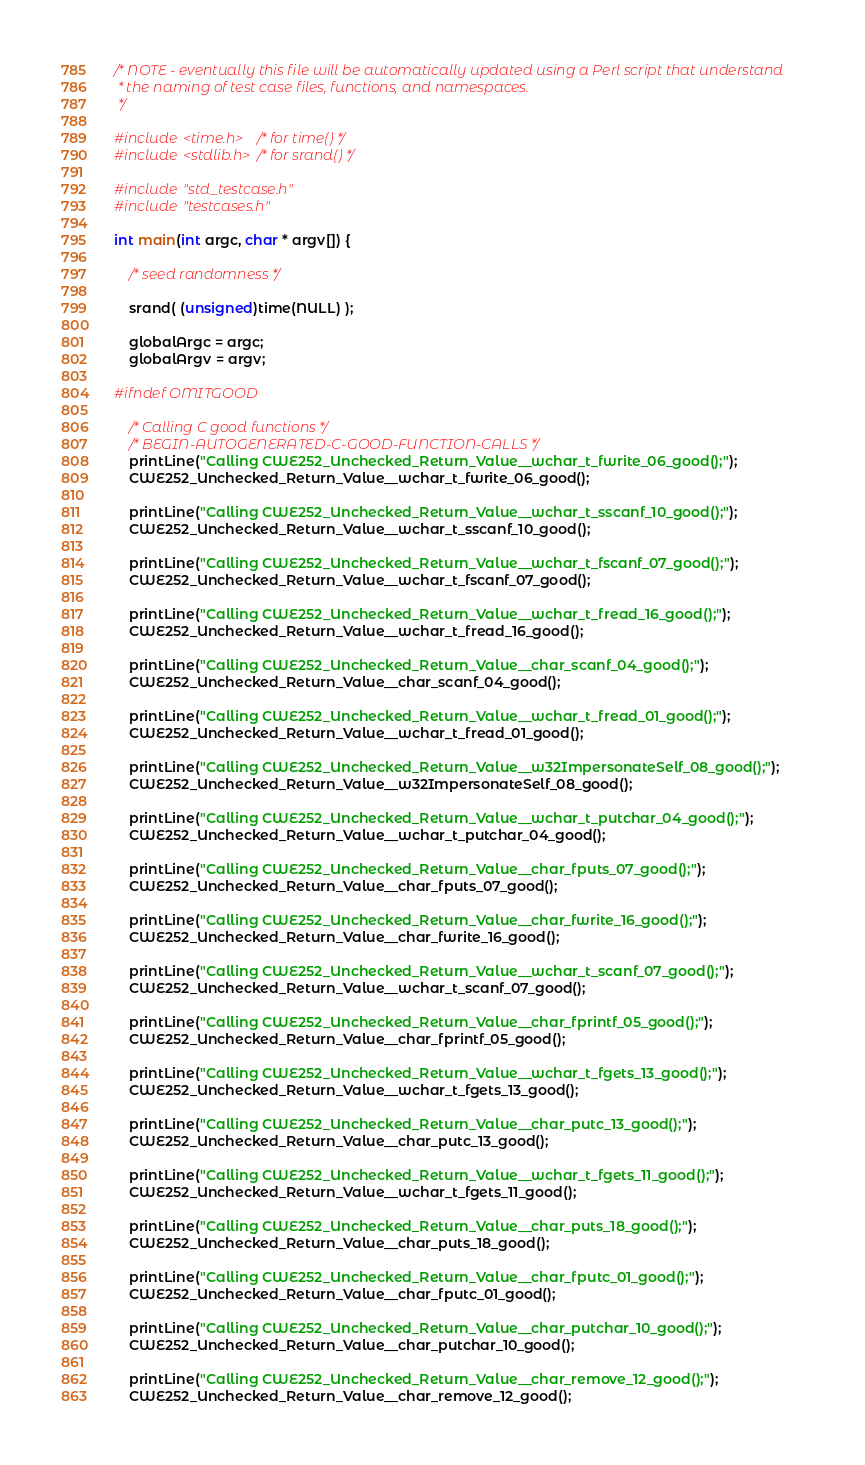<code> <loc_0><loc_0><loc_500><loc_500><_C++_>/* NOTE - eventually this file will be automatically updated using a Perl script that understand
 * the naming of test case files, functions, and namespaces.
 */

#include <time.h>   /* for time() */
#include <stdlib.h> /* for srand() */

#include "std_testcase.h"
#include "testcases.h"

int main(int argc, char * argv[]) {

	/* seed randomness */

	srand( (unsigned)time(NULL) );

	globalArgc = argc;
	globalArgv = argv;

#ifndef OMITGOOD

	/* Calling C good functions */
	/* BEGIN-AUTOGENERATED-C-GOOD-FUNCTION-CALLS */
	printLine("Calling CWE252_Unchecked_Return_Value__wchar_t_fwrite_06_good();");
	CWE252_Unchecked_Return_Value__wchar_t_fwrite_06_good();

	printLine("Calling CWE252_Unchecked_Return_Value__wchar_t_sscanf_10_good();");
	CWE252_Unchecked_Return_Value__wchar_t_sscanf_10_good();

	printLine("Calling CWE252_Unchecked_Return_Value__wchar_t_fscanf_07_good();");
	CWE252_Unchecked_Return_Value__wchar_t_fscanf_07_good();

	printLine("Calling CWE252_Unchecked_Return_Value__wchar_t_fread_16_good();");
	CWE252_Unchecked_Return_Value__wchar_t_fread_16_good();

	printLine("Calling CWE252_Unchecked_Return_Value__char_scanf_04_good();");
	CWE252_Unchecked_Return_Value__char_scanf_04_good();

	printLine("Calling CWE252_Unchecked_Return_Value__wchar_t_fread_01_good();");
	CWE252_Unchecked_Return_Value__wchar_t_fread_01_good();

	printLine("Calling CWE252_Unchecked_Return_Value__w32ImpersonateSelf_08_good();");
	CWE252_Unchecked_Return_Value__w32ImpersonateSelf_08_good();

	printLine("Calling CWE252_Unchecked_Return_Value__wchar_t_putchar_04_good();");
	CWE252_Unchecked_Return_Value__wchar_t_putchar_04_good();

	printLine("Calling CWE252_Unchecked_Return_Value__char_fputs_07_good();");
	CWE252_Unchecked_Return_Value__char_fputs_07_good();

	printLine("Calling CWE252_Unchecked_Return_Value__char_fwrite_16_good();");
	CWE252_Unchecked_Return_Value__char_fwrite_16_good();

	printLine("Calling CWE252_Unchecked_Return_Value__wchar_t_scanf_07_good();");
	CWE252_Unchecked_Return_Value__wchar_t_scanf_07_good();

	printLine("Calling CWE252_Unchecked_Return_Value__char_fprintf_05_good();");
	CWE252_Unchecked_Return_Value__char_fprintf_05_good();

	printLine("Calling CWE252_Unchecked_Return_Value__wchar_t_fgets_13_good();");
	CWE252_Unchecked_Return_Value__wchar_t_fgets_13_good();

	printLine("Calling CWE252_Unchecked_Return_Value__char_putc_13_good();");
	CWE252_Unchecked_Return_Value__char_putc_13_good();

	printLine("Calling CWE252_Unchecked_Return_Value__wchar_t_fgets_11_good();");
	CWE252_Unchecked_Return_Value__wchar_t_fgets_11_good();

	printLine("Calling CWE252_Unchecked_Return_Value__char_puts_18_good();");
	CWE252_Unchecked_Return_Value__char_puts_18_good();

	printLine("Calling CWE252_Unchecked_Return_Value__char_fputc_01_good();");
	CWE252_Unchecked_Return_Value__char_fputc_01_good();

	printLine("Calling CWE252_Unchecked_Return_Value__char_putchar_10_good();");
	CWE252_Unchecked_Return_Value__char_putchar_10_good();

	printLine("Calling CWE252_Unchecked_Return_Value__char_remove_12_good();");
	CWE252_Unchecked_Return_Value__char_remove_12_good();
</code> 